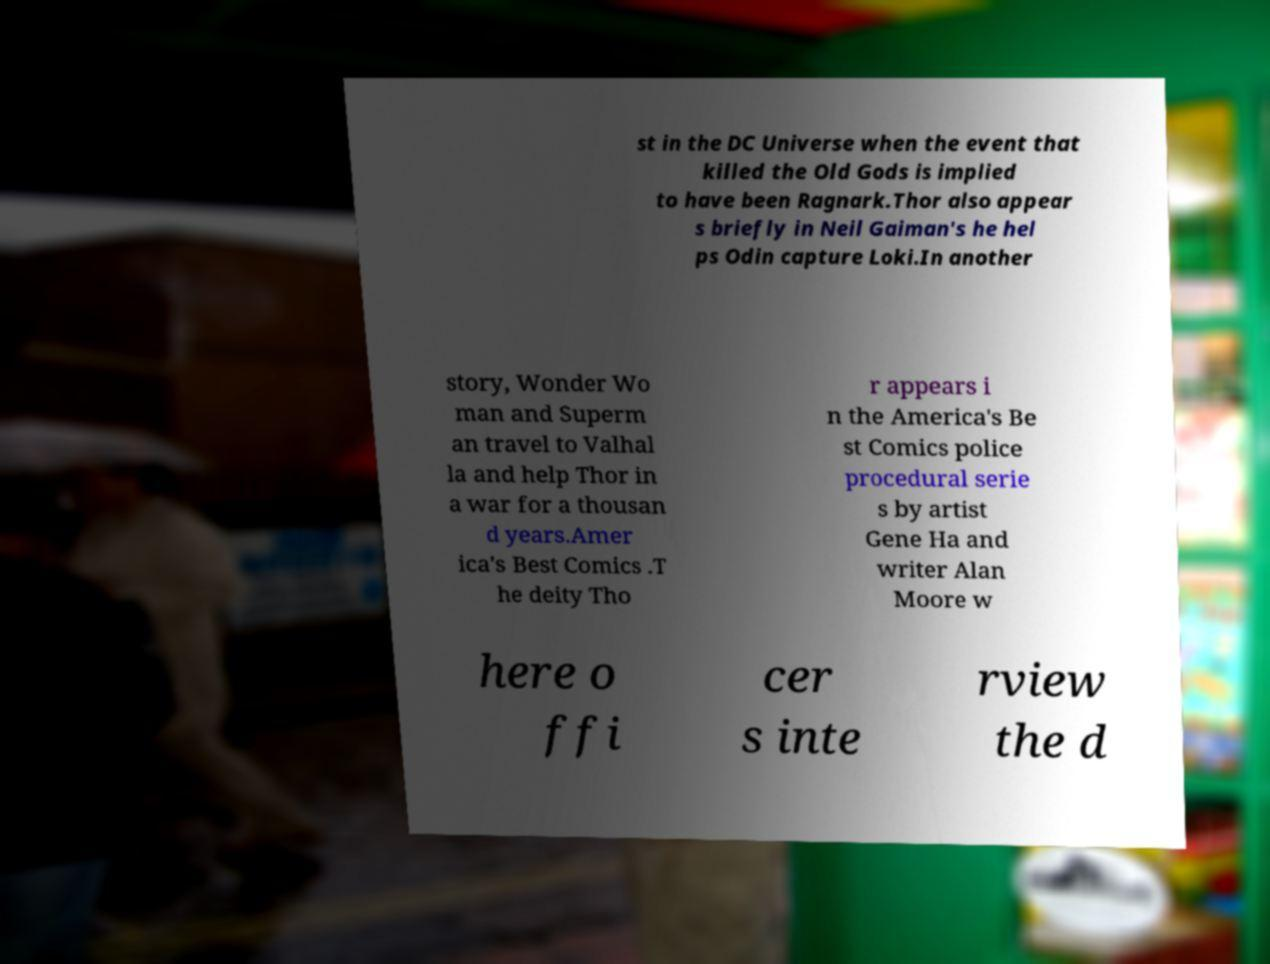Please read and relay the text visible in this image. What does it say? st in the DC Universe when the event that killed the Old Gods is implied to have been Ragnark.Thor also appear s briefly in Neil Gaiman's he hel ps Odin capture Loki.In another story, Wonder Wo man and Superm an travel to Valhal la and help Thor in a war for a thousan d years.Amer ica's Best Comics .T he deity Tho r appears i n the America's Be st Comics police procedural serie s by artist Gene Ha and writer Alan Moore w here o ffi cer s inte rview the d 